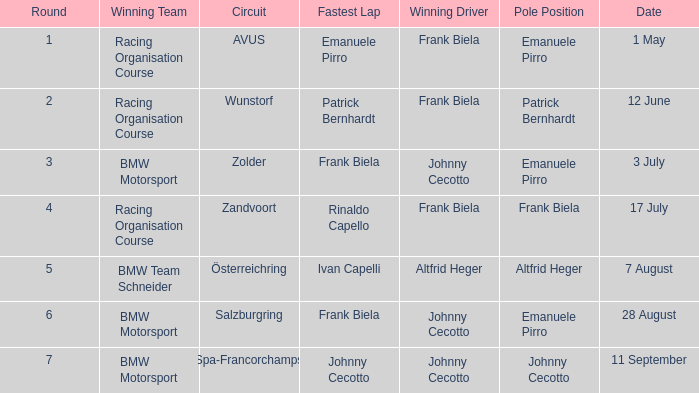What round was circuit Avus? 1.0. 